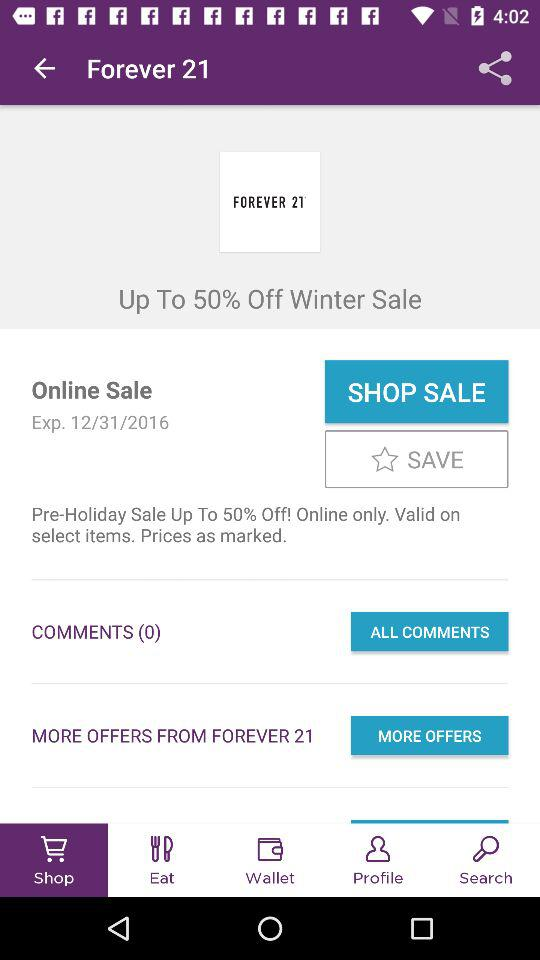How many comments are there on this deal?
Answer the question using a single word or phrase. 0 